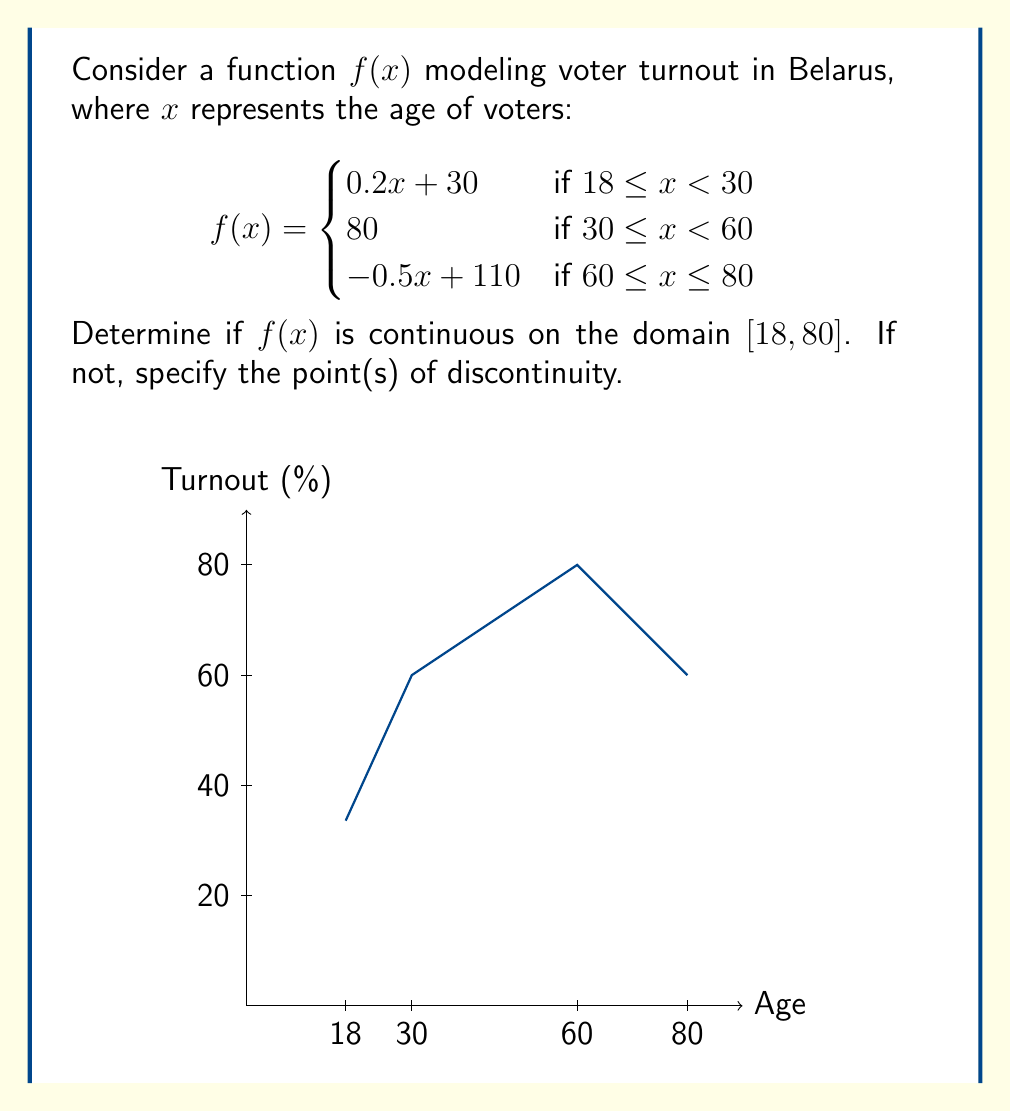Can you answer this question? To determine if $f(x)$ is continuous on $[18, 80]$, we need to check:
1. Continuity within each piece
2. Continuity at the transition points (30 and 60)

Step 1: Continuity within each piece
Each piece of $f(x)$ is a polynomial function, which is continuous on its domain. So, $f(x)$ is continuous on $(18,30)$, $(30,60)$, and $(60,80)$.

Step 2: Continuity at x = 30
Left limit: $\lim_{x \to 30^-} f(x) = 0.2(30) + 30 = 36$
Right limit: $\lim_{x \to 30^+} f(x) = 80$
$f(30) = 80$

Since the left limit ≠ right limit ≠ $f(30)$, $f(x)$ is discontinuous at $x = 30$.

Step 3: Continuity at x = 60
Left limit: $\lim_{x \to 60^-} f(x) = 80$
Right limit: $\lim_{x \to 60^+} f(x) = -0.5(60) + 110 = 80$
$f(60) = 80$

Since left limit = right limit = $f(60)$, $f(x)$ is continuous at $x = 60$.

Step 4: Continuity at endpoints
$f(x)$ is continuous at $x = 18$ and $x = 80$ as these are included in their respective pieces.
Answer: $f(x)$ is discontinuous at $x = 30$. 